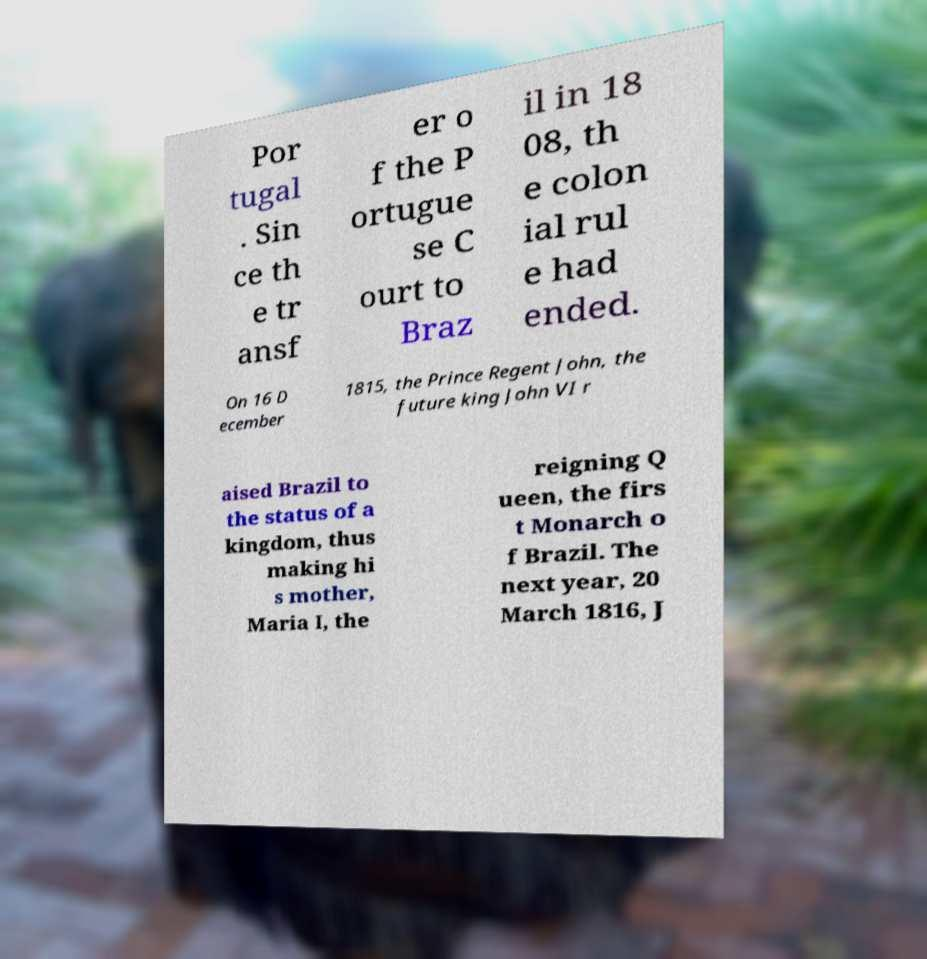Could you assist in decoding the text presented in this image and type it out clearly? Por tugal . Sin ce th e tr ansf er o f the P ortugue se C ourt to Braz il in 18 08, th e colon ial rul e had ended. On 16 D ecember 1815, the Prince Regent John, the future king John VI r aised Brazil to the status of a kingdom, thus making hi s mother, Maria I, the reigning Q ueen, the firs t Monarch o f Brazil. The next year, 20 March 1816, J 